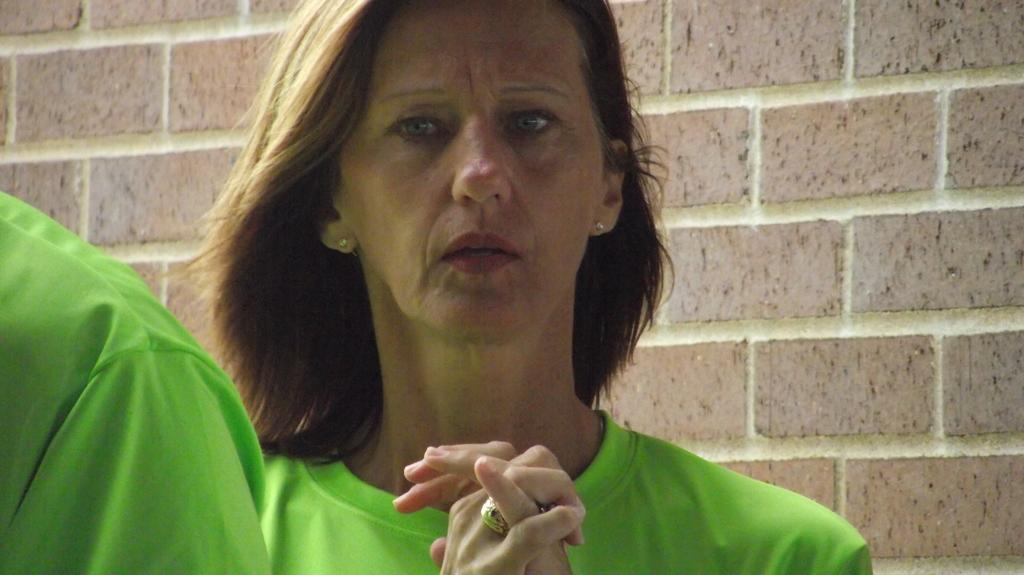What is the main subject of the image? There is a lady standing in the image. Can you describe the person in front of the lady? There is another person in front of the lady. What can be seen in the background of the image? There is a wall with red bricks in the background of the image. Is there a steel dock visible in the image? There is no dock, steel or otherwise, present in the image. 